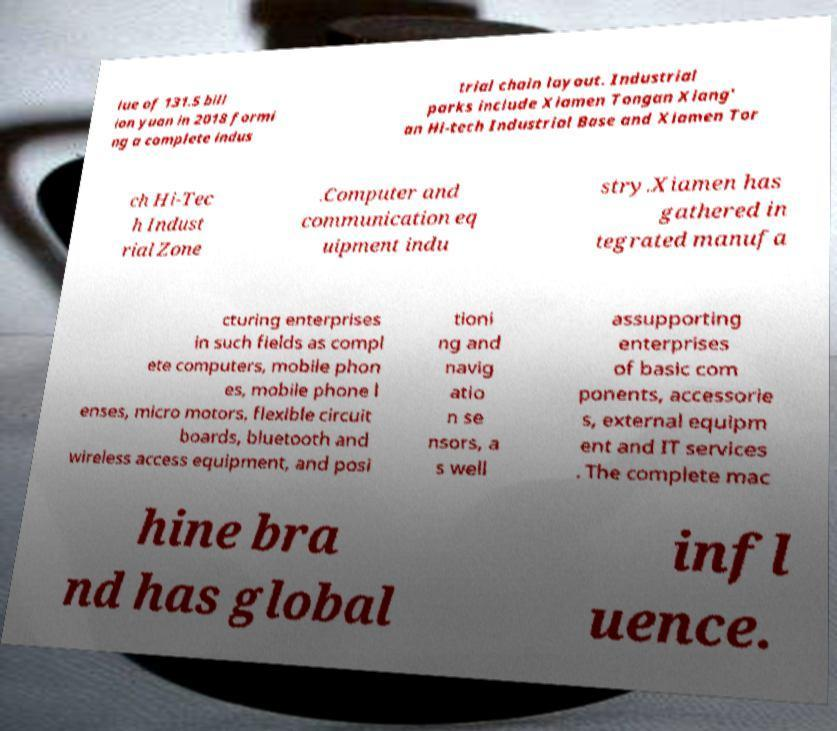Could you extract and type out the text from this image? lue of 131.5 bill ion yuan in 2018 formi ng a complete indus trial chain layout. Industrial parks include Xiamen Tongan Xiang' an Hi-tech Industrial Base and Xiamen Tor ch Hi-Tec h Indust rial Zone .Computer and communication eq uipment indu stry.Xiamen has gathered in tegrated manufa cturing enterprises in such fields as compl ete computers, mobile phon es, mobile phone l enses, micro motors, flexible circuit boards, bluetooth and wireless access equipment, and posi tioni ng and navig atio n se nsors, a s well assupporting enterprises of basic com ponents, accessorie s, external equipm ent and IT services . The complete mac hine bra nd has global infl uence. 